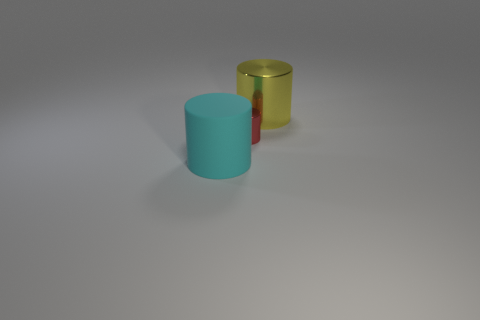Add 3 metallic things. How many objects exist? 6 Subtract 0 brown cylinders. How many objects are left? 3 Subtract all big green rubber cubes. Subtract all large cyan matte objects. How many objects are left? 2 Add 1 big metal cylinders. How many big metal cylinders are left? 2 Add 1 big yellow things. How many big yellow things exist? 2 